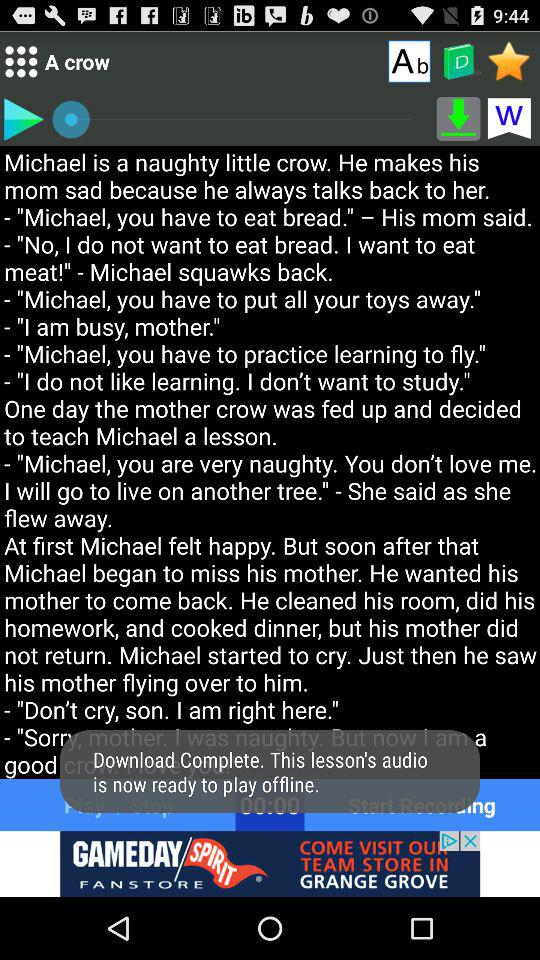What is the status of the lesson audio?
When the provided information is insufficient, respond with <no answer>. <no answer> 